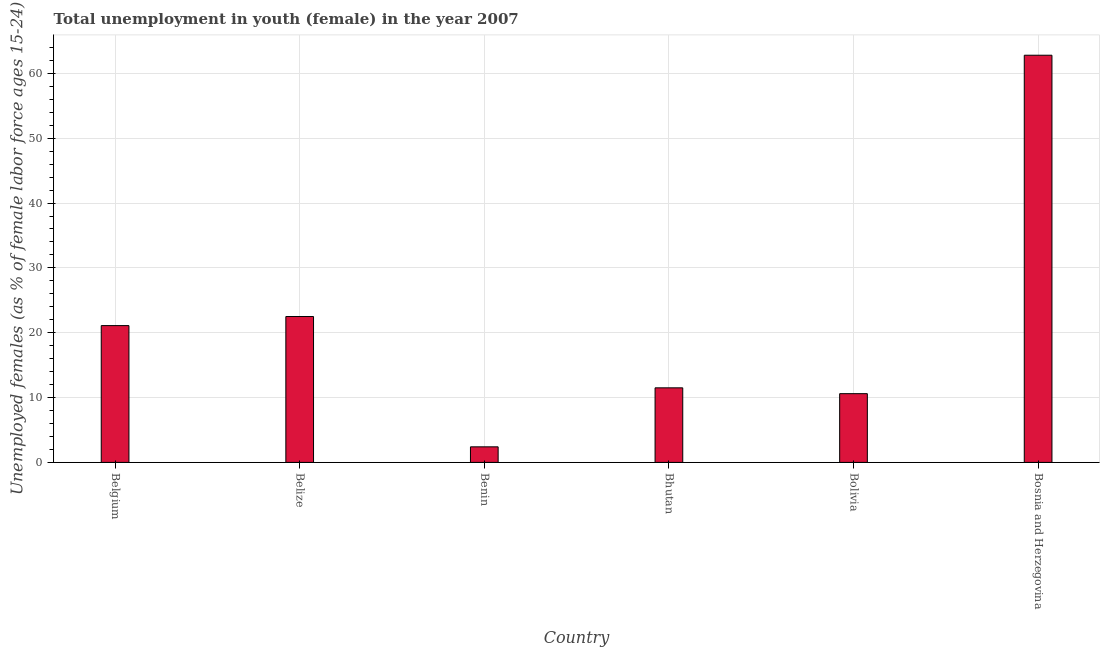Does the graph contain any zero values?
Keep it short and to the point. No. Does the graph contain grids?
Your response must be concise. Yes. What is the title of the graph?
Give a very brief answer. Total unemployment in youth (female) in the year 2007. What is the label or title of the Y-axis?
Offer a very short reply. Unemployed females (as % of female labor force ages 15-24). What is the unemployed female youth population in Bolivia?
Keep it short and to the point. 10.6. Across all countries, what is the maximum unemployed female youth population?
Provide a succinct answer. 62.8. Across all countries, what is the minimum unemployed female youth population?
Your answer should be compact. 2.4. In which country was the unemployed female youth population maximum?
Ensure brevity in your answer.  Bosnia and Herzegovina. In which country was the unemployed female youth population minimum?
Keep it short and to the point. Benin. What is the sum of the unemployed female youth population?
Give a very brief answer. 130.9. What is the difference between the unemployed female youth population in Benin and Bosnia and Herzegovina?
Make the answer very short. -60.4. What is the average unemployed female youth population per country?
Offer a very short reply. 21.82. What is the median unemployed female youth population?
Offer a terse response. 16.3. What is the ratio of the unemployed female youth population in Belize to that in Bolivia?
Ensure brevity in your answer.  2.12. Is the difference between the unemployed female youth population in Benin and Bolivia greater than the difference between any two countries?
Give a very brief answer. No. What is the difference between the highest and the second highest unemployed female youth population?
Offer a terse response. 40.3. Is the sum of the unemployed female youth population in Belize and Bolivia greater than the maximum unemployed female youth population across all countries?
Provide a short and direct response. No. What is the difference between the highest and the lowest unemployed female youth population?
Your answer should be compact. 60.4. In how many countries, is the unemployed female youth population greater than the average unemployed female youth population taken over all countries?
Make the answer very short. 2. Are all the bars in the graph horizontal?
Ensure brevity in your answer.  No. How many countries are there in the graph?
Keep it short and to the point. 6. Are the values on the major ticks of Y-axis written in scientific E-notation?
Offer a very short reply. No. What is the Unemployed females (as % of female labor force ages 15-24) in Belgium?
Offer a very short reply. 21.1. What is the Unemployed females (as % of female labor force ages 15-24) of Belize?
Offer a terse response. 22.5. What is the Unemployed females (as % of female labor force ages 15-24) in Benin?
Give a very brief answer. 2.4. What is the Unemployed females (as % of female labor force ages 15-24) in Bolivia?
Provide a short and direct response. 10.6. What is the Unemployed females (as % of female labor force ages 15-24) in Bosnia and Herzegovina?
Give a very brief answer. 62.8. What is the difference between the Unemployed females (as % of female labor force ages 15-24) in Belgium and Bhutan?
Offer a very short reply. 9.6. What is the difference between the Unemployed females (as % of female labor force ages 15-24) in Belgium and Bolivia?
Offer a very short reply. 10.5. What is the difference between the Unemployed females (as % of female labor force ages 15-24) in Belgium and Bosnia and Herzegovina?
Offer a terse response. -41.7. What is the difference between the Unemployed females (as % of female labor force ages 15-24) in Belize and Benin?
Offer a very short reply. 20.1. What is the difference between the Unemployed females (as % of female labor force ages 15-24) in Belize and Bolivia?
Provide a short and direct response. 11.9. What is the difference between the Unemployed females (as % of female labor force ages 15-24) in Belize and Bosnia and Herzegovina?
Give a very brief answer. -40.3. What is the difference between the Unemployed females (as % of female labor force ages 15-24) in Benin and Bolivia?
Make the answer very short. -8.2. What is the difference between the Unemployed females (as % of female labor force ages 15-24) in Benin and Bosnia and Herzegovina?
Your response must be concise. -60.4. What is the difference between the Unemployed females (as % of female labor force ages 15-24) in Bhutan and Bosnia and Herzegovina?
Your answer should be very brief. -51.3. What is the difference between the Unemployed females (as % of female labor force ages 15-24) in Bolivia and Bosnia and Herzegovina?
Keep it short and to the point. -52.2. What is the ratio of the Unemployed females (as % of female labor force ages 15-24) in Belgium to that in Belize?
Your answer should be very brief. 0.94. What is the ratio of the Unemployed females (as % of female labor force ages 15-24) in Belgium to that in Benin?
Keep it short and to the point. 8.79. What is the ratio of the Unemployed females (as % of female labor force ages 15-24) in Belgium to that in Bhutan?
Keep it short and to the point. 1.83. What is the ratio of the Unemployed females (as % of female labor force ages 15-24) in Belgium to that in Bolivia?
Provide a succinct answer. 1.99. What is the ratio of the Unemployed females (as % of female labor force ages 15-24) in Belgium to that in Bosnia and Herzegovina?
Provide a short and direct response. 0.34. What is the ratio of the Unemployed females (as % of female labor force ages 15-24) in Belize to that in Benin?
Give a very brief answer. 9.38. What is the ratio of the Unemployed females (as % of female labor force ages 15-24) in Belize to that in Bhutan?
Provide a succinct answer. 1.96. What is the ratio of the Unemployed females (as % of female labor force ages 15-24) in Belize to that in Bolivia?
Your answer should be compact. 2.12. What is the ratio of the Unemployed females (as % of female labor force ages 15-24) in Belize to that in Bosnia and Herzegovina?
Offer a terse response. 0.36. What is the ratio of the Unemployed females (as % of female labor force ages 15-24) in Benin to that in Bhutan?
Offer a terse response. 0.21. What is the ratio of the Unemployed females (as % of female labor force ages 15-24) in Benin to that in Bolivia?
Your response must be concise. 0.23. What is the ratio of the Unemployed females (as % of female labor force ages 15-24) in Benin to that in Bosnia and Herzegovina?
Keep it short and to the point. 0.04. What is the ratio of the Unemployed females (as % of female labor force ages 15-24) in Bhutan to that in Bolivia?
Your answer should be very brief. 1.08. What is the ratio of the Unemployed females (as % of female labor force ages 15-24) in Bhutan to that in Bosnia and Herzegovina?
Provide a short and direct response. 0.18. What is the ratio of the Unemployed females (as % of female labor force ages 15-24) in Bolivia to that in Bosnia and Herzegovina?
Provide a short and direct response. 0.17. 